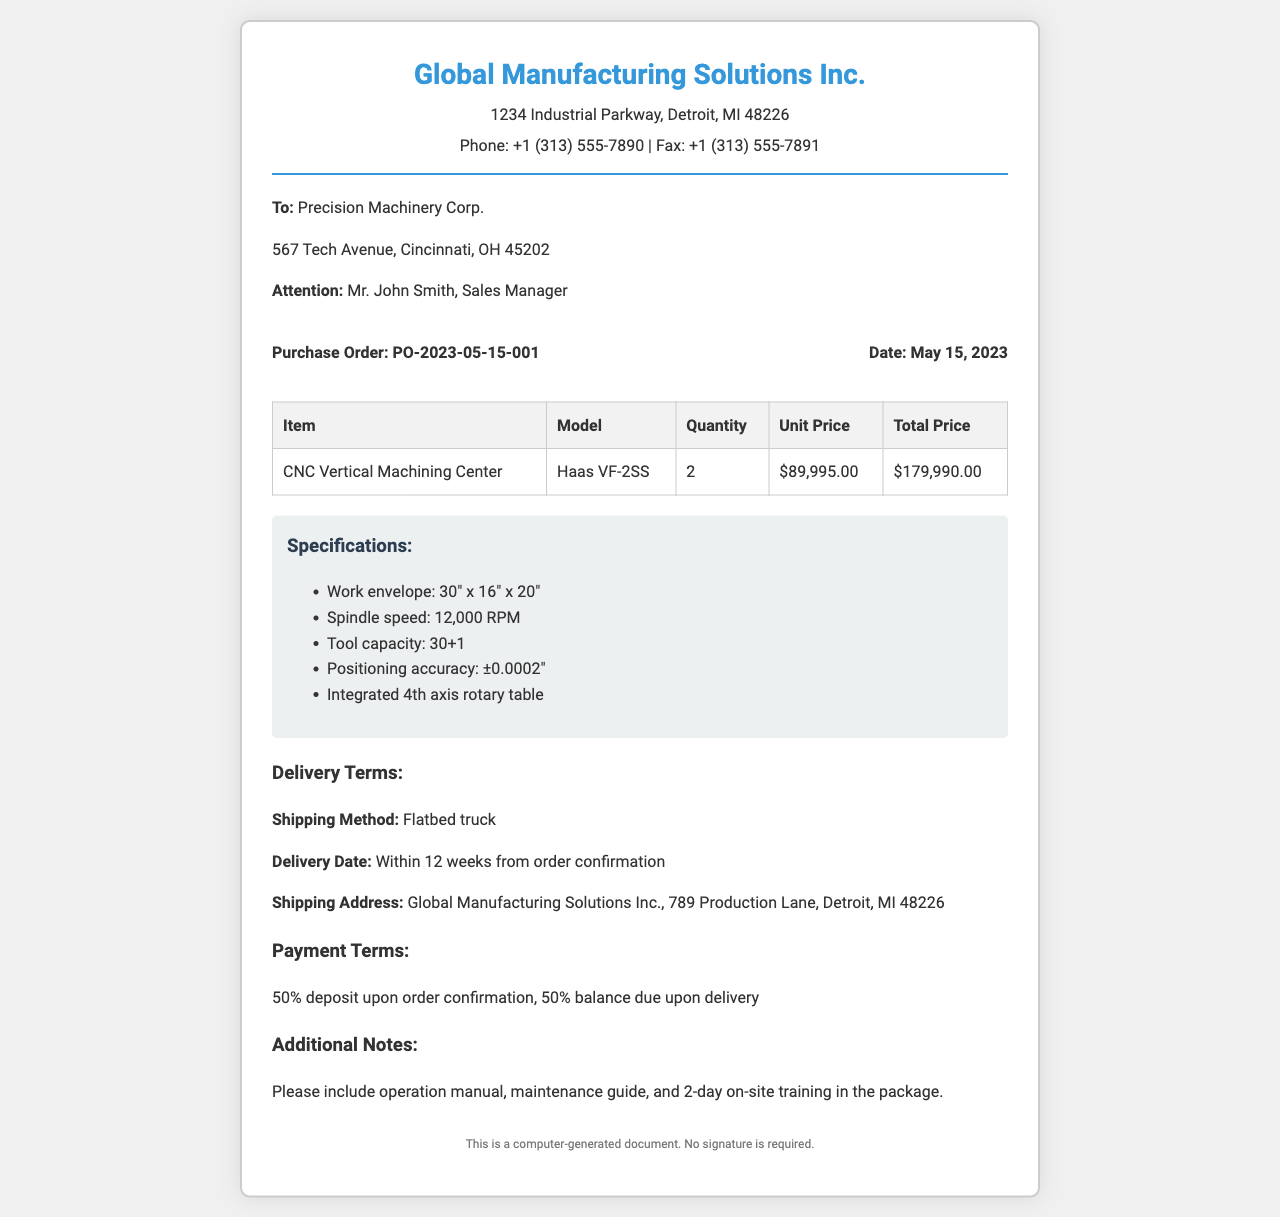What is the purchase order number? The purchase order number is specified at the top of the order details section.
Answer: PO-2023-05-15-001 What is the model of the CNC Vertical Machining Center? The model is clearly stated in the item details of the order.
Answer: Haas VF-2SS How many units of the machinery are being ordered? The quantity is mentioned in the order details section.
Answer: 2 What is the total price for the CNC Vertical Machining Center? The total price can be calculated from the order details, it is the sum of the unit price multiplied by the quantity.
Answer: $179,990.00 What is the delivery method for the machinery? The shipping method is specified under delivery terms in the document.
Answer: Flatbed truck When is the delivery date expected? The delivery date is indicated under delivery terms as being time-sensitive.
Answer: Within 12 weeks from order confirmation What percentage of the payment is required as a deposit? The payment terms section states the deposit requirement as a percentage.
Answer: 50% What additional materials are requested with the order? The additional notes section highlights specific materials and services.
Answer: Operation manual, maintenance guide, and 2-day on-site training 